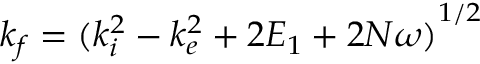<formula> <loc_0><loc_0><loc_500><loc_500>{ k _ { f } } = { ( k _ { i } ^ { 2 } - k _ { e } ^ { 2 } + 2 E _ { 1 } + 2 N \omega ) } ^ { 1 / 2 }</formula> 